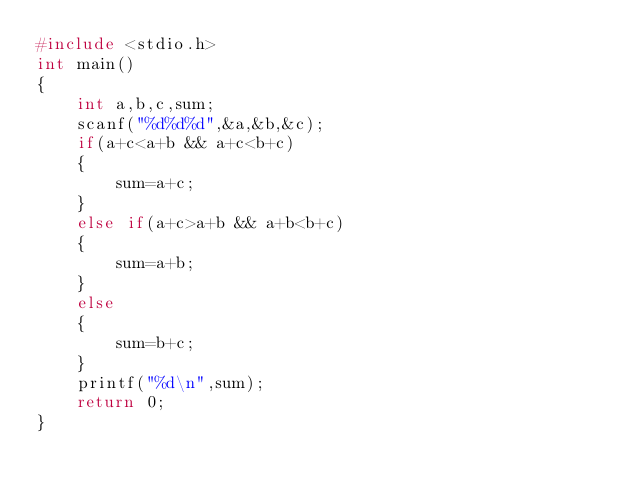<code> <loc_0><loc_0><loc_500><loc_500><_C_>#include <stdio.h>
int main()
{
    int a,b,c,sum;
    scanf("%d%d%d",&a,&b,&c);
    if(a+c<a+b && a+c<b+c)
    {
        sum=a+c;
    }
    else if(a+c>a+b && a+b<b+c)
    {
        sum=a+b;
    }
    else
    {
        sum=b+c;
    }
    printf("%d\n",sum);
    return 0;
}</code> 